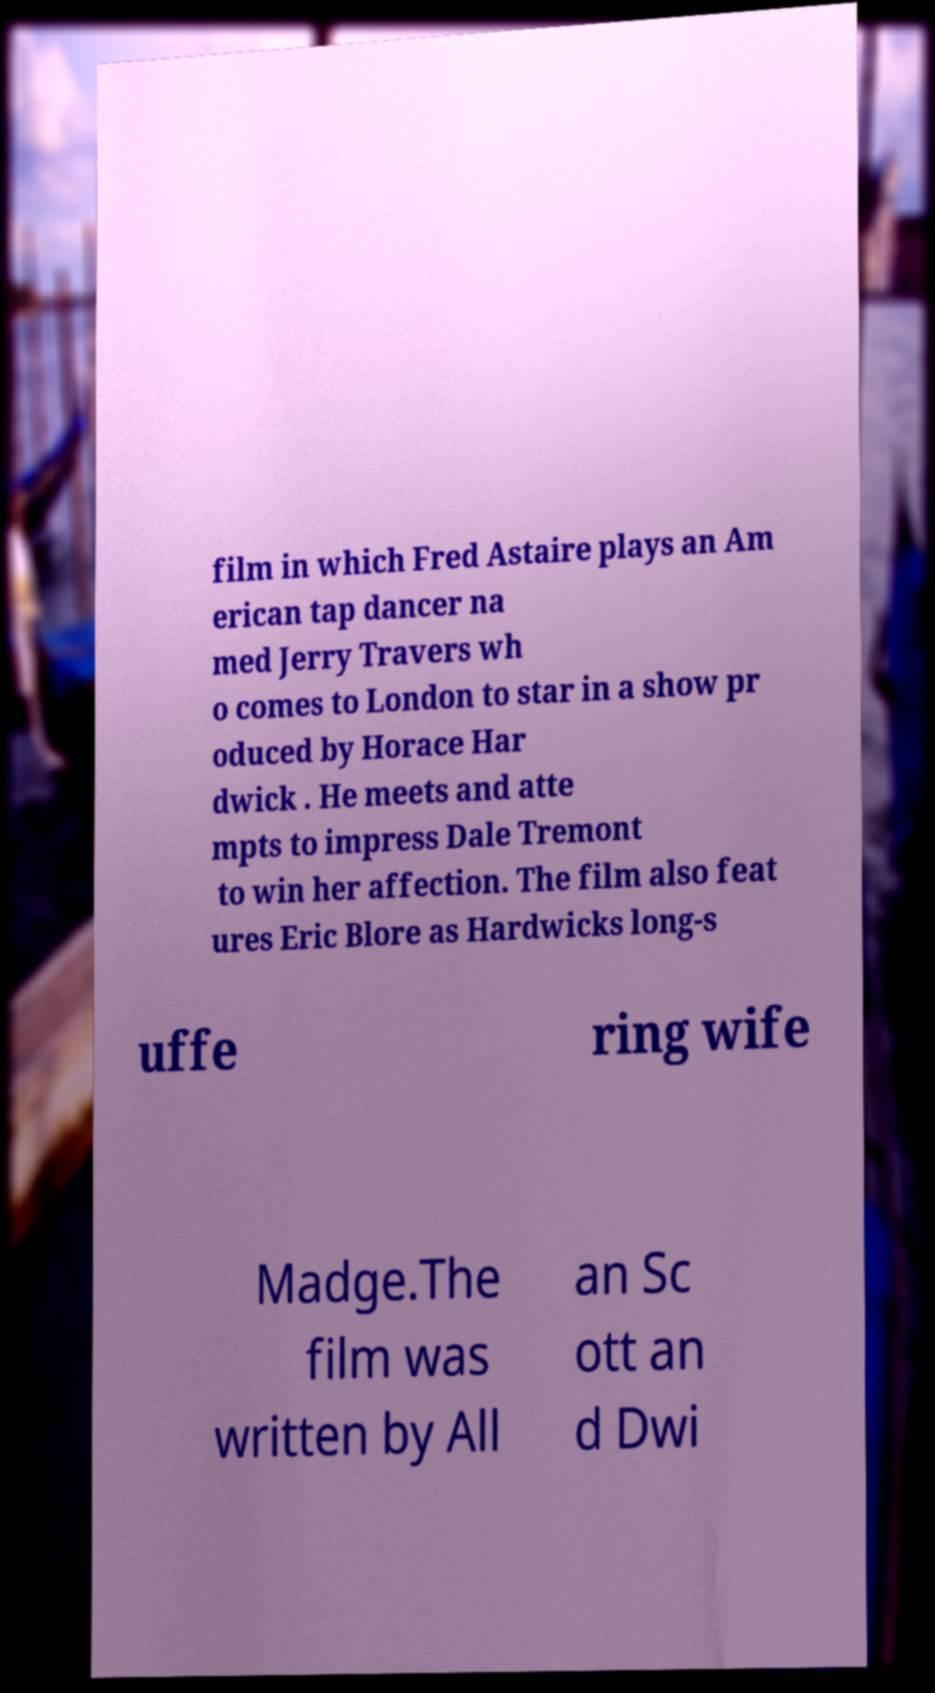Could you assist in decoding the text presented in this image and type it out clearly? film in which Fred Astaire plays an Am erican tap dancer na med Jerry Travers wh o comes to London to star in a show pr oduced by Horace Har dwick . He meets and atte mpts to impress Dale Tremont to win her affection. The film also feat ures Eric Blore as Hardwicks long-s uffe ring wife Madge.The film was written by All an Sc ott an d Dwi 